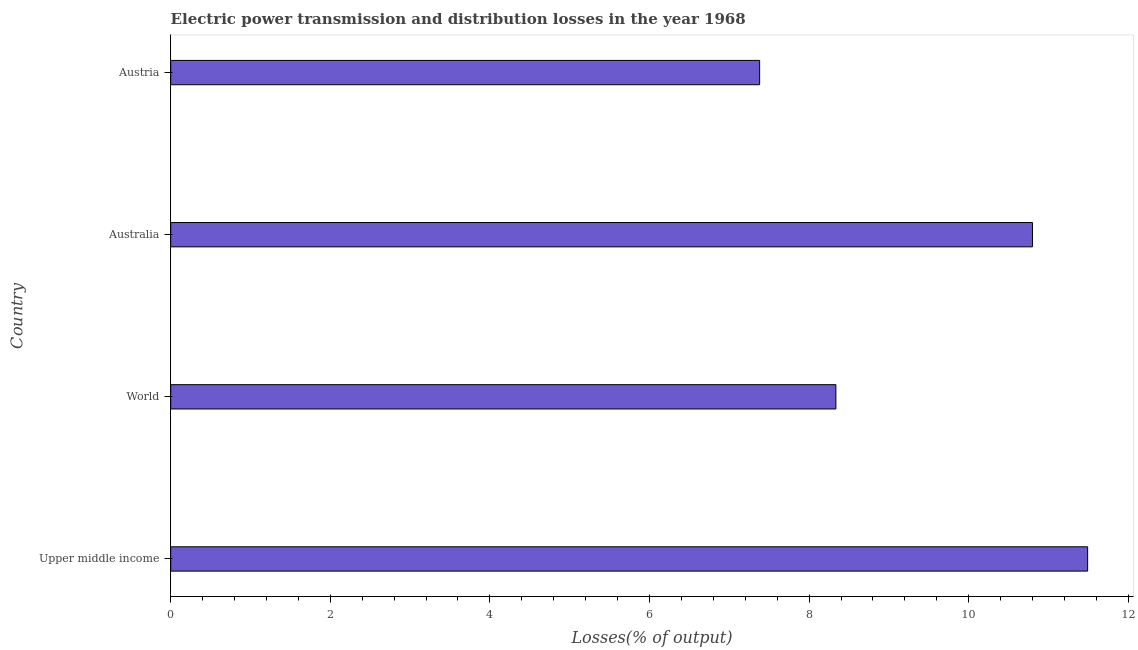Does the graph contain any zero values?
Give a very brief answer. No. Does the graph contain grids?
Give a very brief answer. No. What is the title of the graph?
Offer a very short reply. Electric power transmission and distribution losses in the year 1968. What is the label or title of the X-axis?
Make the answer very short. Losses(% of output). What is the label or title of the Y-axis?
Your response must be concise. Country. What is the electric power transmission and distribution losses in Austria?
Give a very brief answer. 7.38. Across all countries, what is the maximum electric power transmission and distribution losses?
Keep it short and to the point. 11.49. Across all countries, what is the minimum electric power transmission and distribution losses?
Offer a terse response. 7.38. In which country was the electric power transmission and distribution losses maximum?
Provide a short and direct response. Upper middle income. In which country was the electric power transmission and distribution losses minimum?
Offer a terse response. Austria. What is the sum of the electric power transmission and distribution losses?
Your response must be concise. 38.01. What is the difference between the electric power transmission and distribution losses in Upper middle income and World?
Provide a short and direct response. 3.15. What is the average electric power transmission and distribution losses per country?
Give a very brief answer. 9.5. What is the median electric power transmission and distribution losses?
Ensure brevity in your answer.  9.57. In how many countries, is the electric power transmission and distribution losses greater than 0.4 %?
Offer a very short reply. 4. What is the ratio of the electric power transmission and distribution losses in Upper middle income to that in World?
Your response must be concise. 1.38. Is the difference between the electric power transmission and distribution losses in Australia and Upper middle income greater than the difference between any two countries?
Offer a terse response. No. What is the difference between the highest and the second highest electric power transmission and distribution losses?
Your answer should be compact. 0.69. What is the difference between the highest and the lowest electric power transmission and distribution losses?
Keep it short and to the point. 4.11. In how many countries, is the electric power transmission and distribution losses greater than the average electric power transmission and distribution losses taken over all countries?
Provide a short and direct response. 2. How many bars are there?
Ensure brevity in your answer.  4. Are all the bars in the graph horizontal?
Your answer should be compact. Yes. Are the values on the major ticks of X-axis written in scientific E-notation?
Your answer should be compact. No. What is the Losses(% of output) of Upper middle income?
Give a very brief answer. 11.49. What is the Losses(% of output) of World?
Your answer should be very brief. 8.34. What is the Losses(% of output) in Australia?
Provide a short and direct response. 10.8. What is the Losses(% of output) of Austria?
Make the answer very short. 7.38. What is the difference between the Losses(% of output) in Upper middle income and World?
Offer a terse response. 3.15. What is the difference between the Losses(% of output) in Upper middle income and Australia?
Your response must be concise. 0.69. What is the difference between the Losses(% of output) in Upper middle income and Austria?
Offer a terse response. 4.11. What is the difference between the Losses(% of output) in World and Australia?
Your response must be concise. -2.46. What is the difference between the Losses(% of output) in World and Austria?
Your answer should be very brief. 0.96. What is the difference between the Losses(% of output) in Australia and Austria?
Provide a short and direct response. 3.42. What is the ratio of the Losses(% of output) in Upper middle income to that in World?
Offer a terse response. 1.38. What is the ratio of the Losses(% of output) in Upper middle income to that in Australia?
Provide a short and direct response. 1.06. What is the ratio of the Losses(% of output) in Upper middle income to that in Austria?
Provide a succinct answer. 1.56. What is the ratio of the Losses(% of output) in World to that in Australia?
Make the answer very short. 0.77. What is the ratio of the Losses(% of output) in World to that in Austria?
Provide a succinct answer. 1.13. What is the ratio of the Losses(% of output) in Australia to that in Austria?
Offer a terse response. 1.46. 